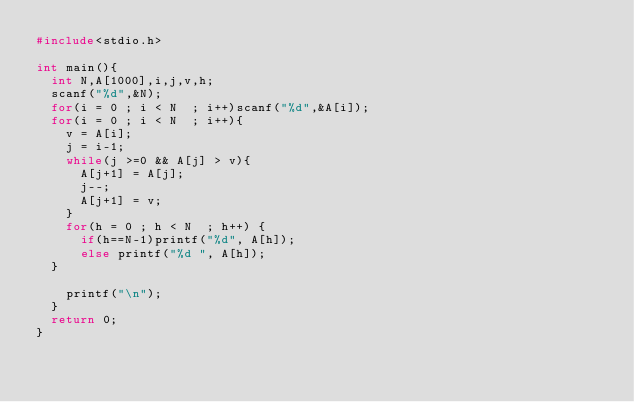Convert code to text. <code><loc_0><loc_0><loc_500><loc_500><_C_>#include<stdio.h>

int main(){
  int N,A[1000],i,j,v,h;
  scanf("%d",&N);
  for(i = 0 ; i < N  ; i++)scanf("%d",&A[i]);
  for(i = 0 ; i < N  ; i++){
    v = A[i];
    j = i-1;
    while(j >=0 && A[j] > v){
      A[j+1] = A[j];
      j--;
      A[j+1] = v;
    }
    for(h = 0 ; h < N  ; h++) {
      if(h==N-1)printf("%d", A[h]);
      else printf("%d ", A[h]);
  }
  
    printf("\n");
  }
  return 0;
}

</code> 